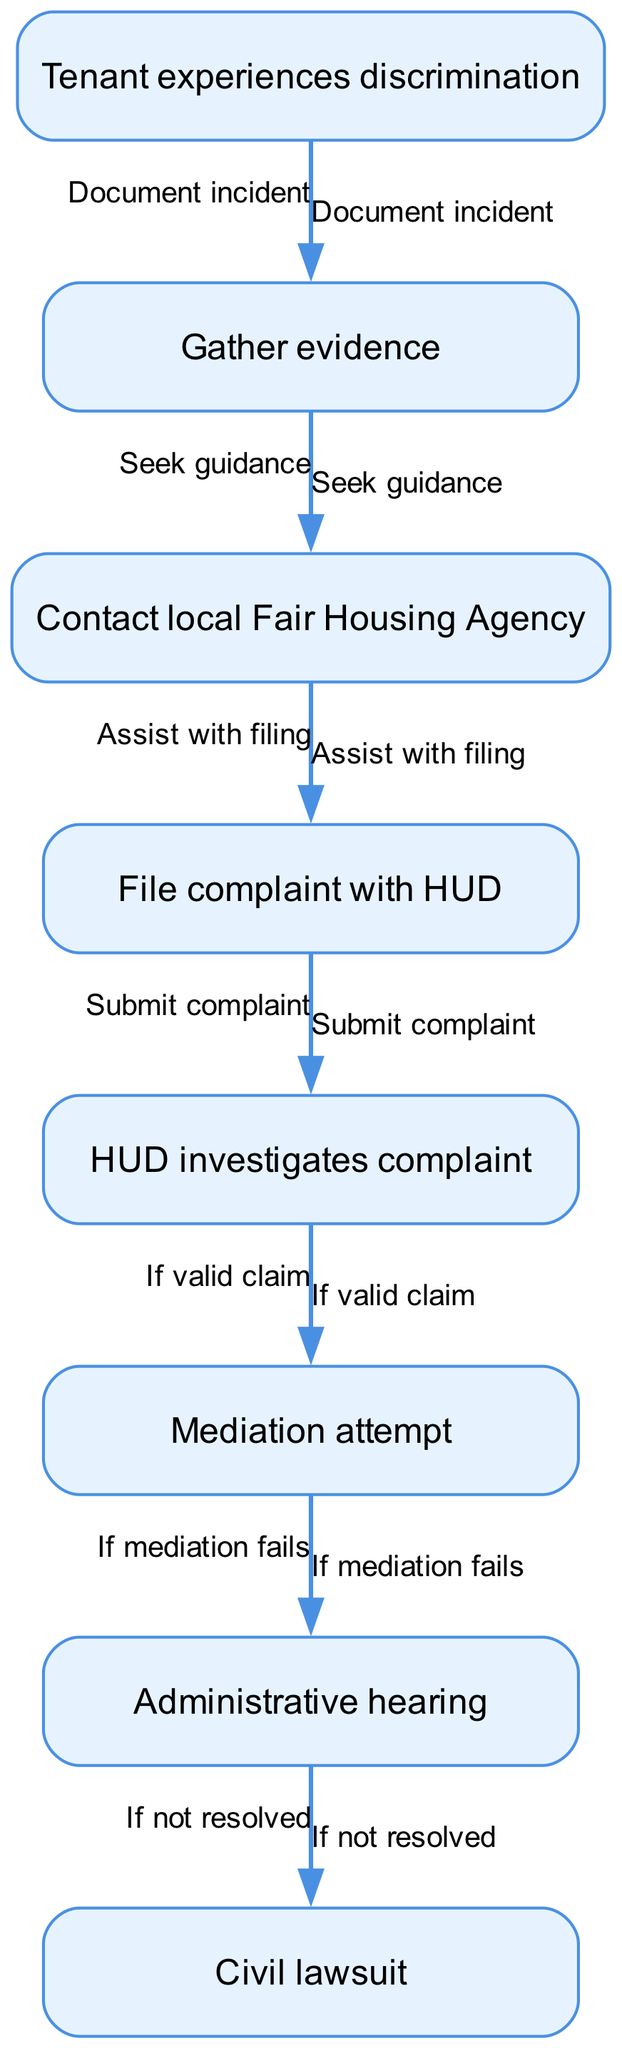What is the first step in the complaint process? The first node in the flowchart is "Tenant experiences discrimination," indicating that the process begins when a tenant experiences a discriminatory incident.
Answer: Tenant experiences discrimination How many nodes are in the diagram? The diagram contains a total of 8 nodes, each representing a step in the housing discrimination complaint process.
Answer: 8 What does the node "Gather evidence" lead to? The edge coming from "Gather evidence" leads to the node "Contact local Fair Housing Agency," indicating that after gathering evidence, the next step is to seek guidance from a Fair Housing Agency.
Answer: Contact local Fair Housing Agency What happens if a complaint is valid? If the complaint is valid, HUD will proceed with an investigation, leading to the next node "Mediation attempt" as described in the flowchart.
Answer: Mediation attempt If mediation fails, what is the next step? Following the node "Mediation attempt," if mediation fails, the flowchart shows the next step is "Administrative hearing," indicating that further legal action is considered.
Answer: Administrative hearing What is the final outcome if the administrative hearing does not resolve the issue? After the node "Administrative hearing," if the issue is still not resolved, the flowchart indicates that the tenant may proceed to file a "Civil lawsuit" as the final outcome.
Answer: Civil lawsuit What is the purpose of the edge labeled "If valid claim"? This edge connects "HUD investigates complaint" to "Mediation attempt," signifying that the investigation only leads to mediation if the claim is determined to be valid.
Answer: Mediation attempt Which node comes after "File complaint with HUD"? The node that follows "File complaint with HUD" is "HUD investigates complaint," indicating that filing triggers an investigative process by HUD.
Answer: HUD investigates complaint 